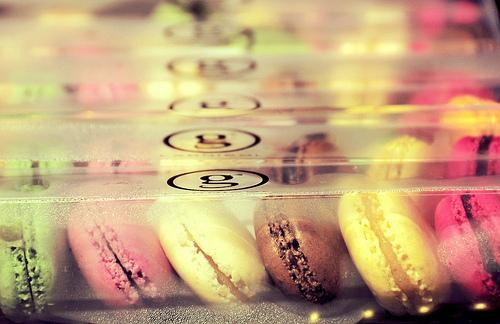In a conversational tone, describe the main focus of the image. You know, there's this really appetizing photo of colorful French macarons! They're neatly arranged in these clear containers, showing off six amazing flavors to choose from. Mention the primary focal point in the image and its characteristics. The primary focal point is a collection of colorful French macarons in clear boxes, featuring six vibrant and diverse flavors. Provide a general description of the items captured in the image. A variety of colorful macarons are displayed in clear plastic containers with a manufacturer's logo, showcasing six different flavors. Describe the major components in the photograph using a poetic tone. An exquisite mosaic of delight, French macarons in vibrant hues lie nestled within their crystal casings, inviting the senses to indulge in six assorted flavors. Talk about the purpose of the image and what it represents. The image showcases a delectable assortment of French macarons in clear packaging, highlighting the manufacturer's logo and the choice of six flavors for consumers. Use sensory language to describe the overall appearance of the image. Visually enticing macarons in vivid shades of pink, yellow, and green are neatly arranged within transparent containers, exhibiting an array of mouth-watering flavors. Describe the positioning of the colorful macarons in the image. The macarons are organized in rows inside clear plastic containers, showcasing their vibrant colors and various flavors. Write a concise description of the image in a single sentence. Colorful French macarons are displayed in transparent containers, featuring a manufacturer's logo and six tempting flavors. In the style of an advertisement, describe the contents of the image. Introducing our tantalizing variety of French macarons! A symphony of six delightful flavors, nestled in elegant clear packaging, embellished with our distinguished logo - the ultimate treat for your senses! Mention the visual aspect that stands out the most in the image. The bright colors of the French macarons catch the eye, as they are displayed in transparent boxes revealing their distinct and diverse flavors. 